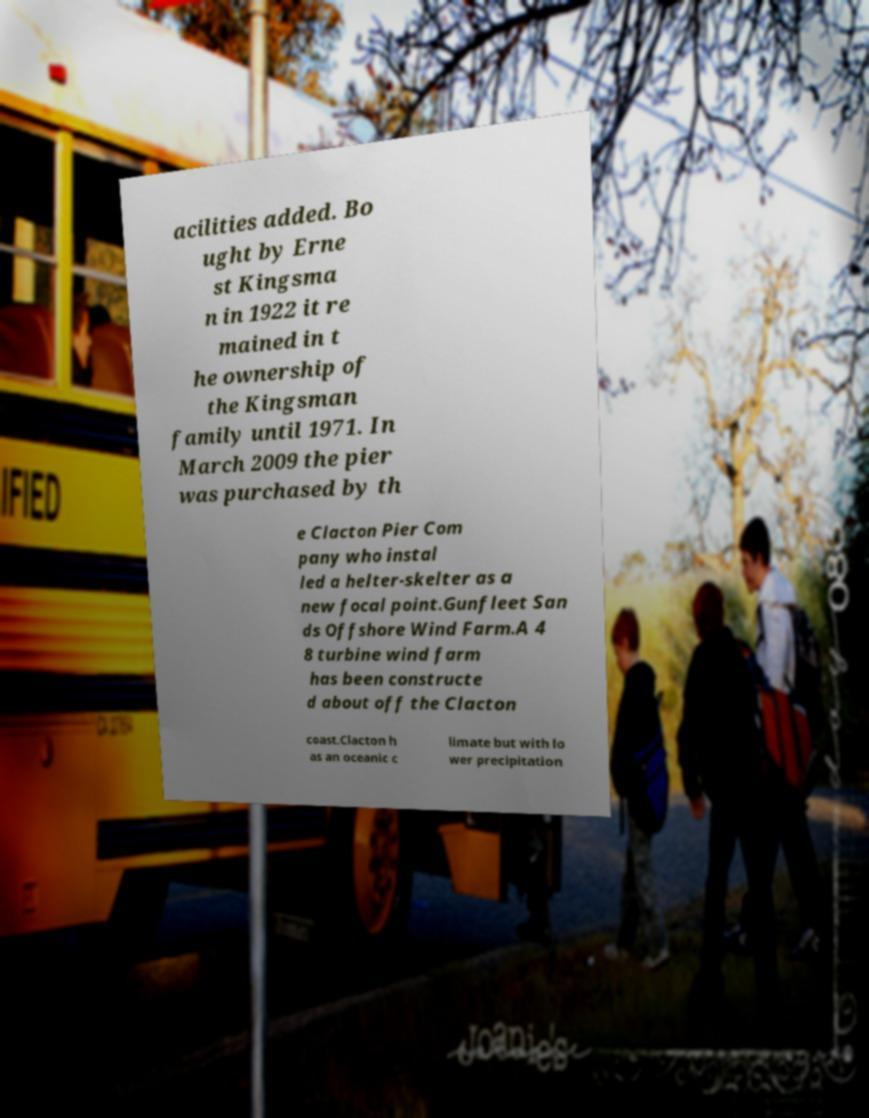For documentation purposes, I need the text within this image transcribed. Could you provide that? acilities added. Bo ught by Erne st Kingsma n in 1922 it re mained in t he ownership of the Kingsman family until 1971. In March 2009 the pier was purchased by th e Clacton Pier Com pany who instal led a helter-skelter as a new focal point.Gunfleet San ds Offshore Wind Farm.A 4 8 turbine wind farm has been constructe d about off the Clacton coast.Clacton h as an oceanic c limate but with lo wer precipitation 